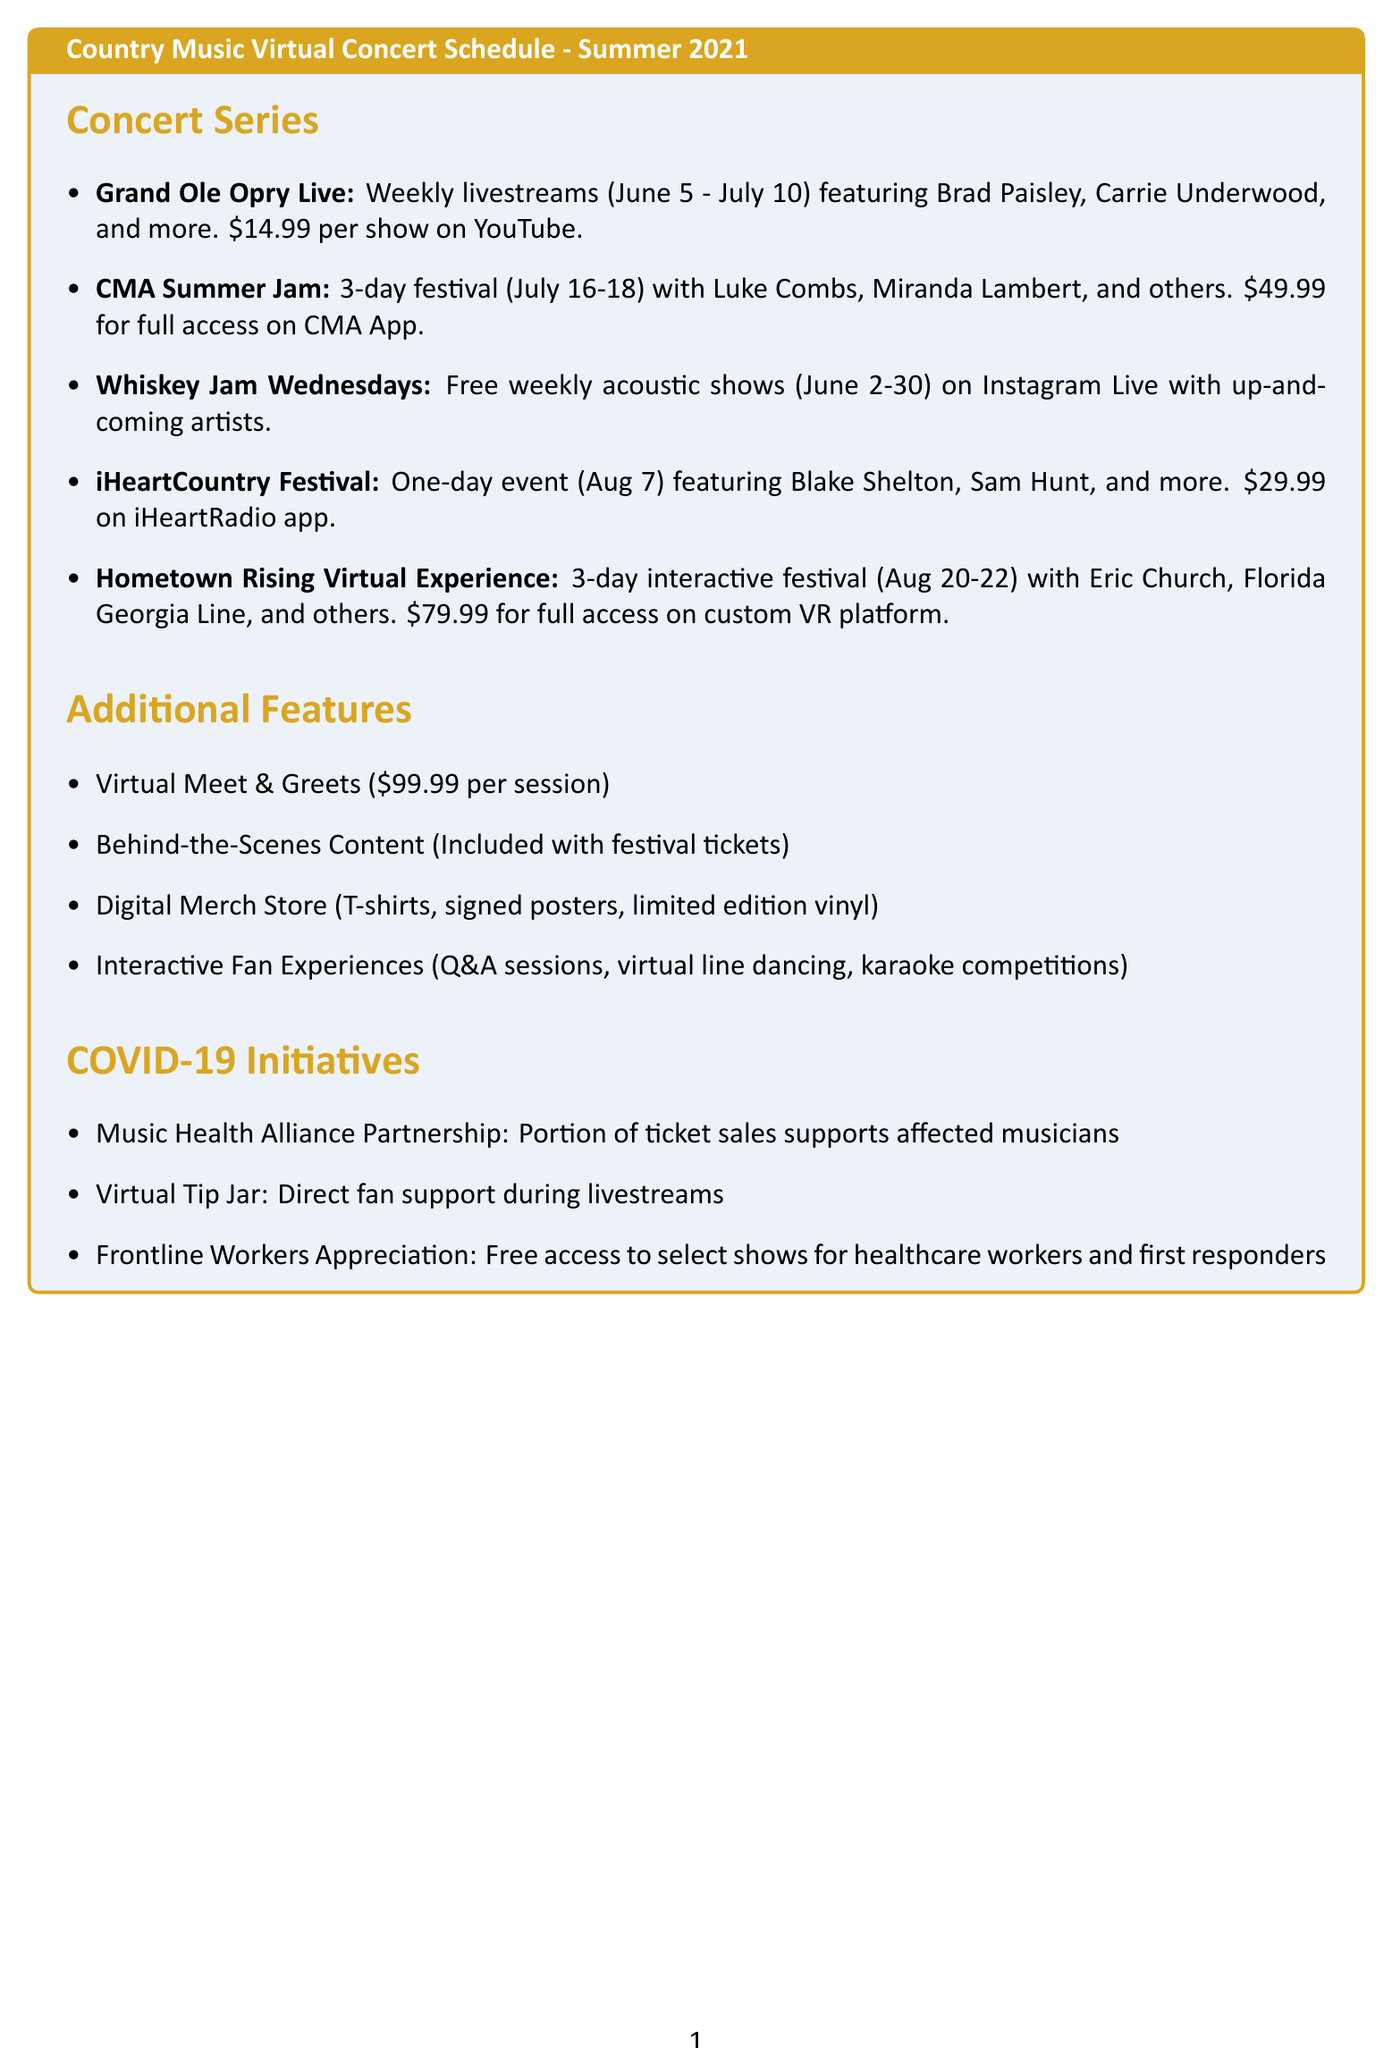What is the platform for Grand Ole Opry Live? The platform for Grand Ole Opry Live is mentioned in the document as YouTube.
Answer: YouTube How many performers are featured in CMA Summer Jam? The CMA Summer Jam features a list of six performers according to the document.
Answer: 6 What is the ticket price for Whiskey Jam Wednesdays? The document states that the ticket price for Whiskey Jam Wednesdays is free.
Answer: Free On what date does the iHeartCountry Festival take place? The document specifically mentions August 7, 2021, as the date for the iHeartCountry Festival.
Answer: August 7, 2021 Which initiative provides free access to select performances for healthcare workers? According to the document, the initiative is called Frontline Workers Appreciation.
Answer: Frontline Workers Appreciation What are the dates for the Hometown Rising Virtual Experience? The dates listed in the document for this event are August 20-22, 2021.
Answer: August 20-22, 2021 How much does a Virtual Meet & Greet cost? The document specifies that a Virtual Meet & Greet costs $99.99 per session.
Answer: $99.99 What type of performances are included in Whiskey Jam Wednesdays? The document indicates that Whiskey Jam Wednesdays feature acoustic performances by up-and-coming country artists.
Answer: Acoustic performances What is the ticket price for full access to the CMA Summer Jam? The document states that full access to the CMA Summer Jam costs $49.99.
Answer: $49.99 